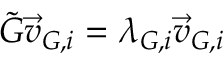Convert formula to latex. <formula><loc_0><loc_0><loc_500><loc_500>\tilde { G } \overrightarrow { v } _ { G , i } = \lambda _ { G , i } \overrightarrow { v } _ { G , i }</formula> 